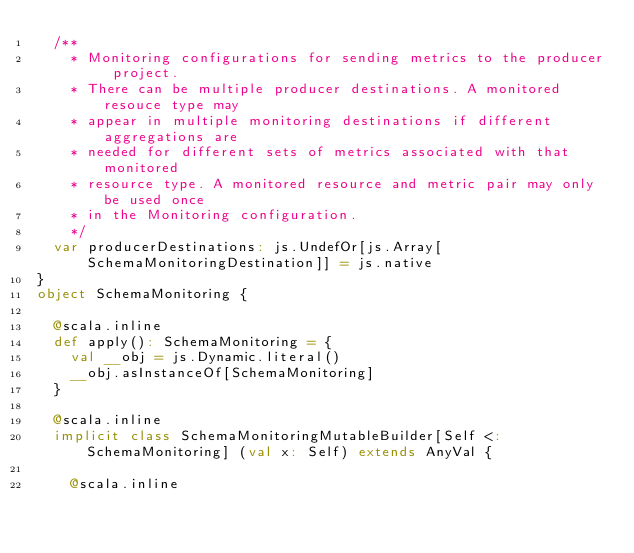<code> <loc_0><loc_0><loc_500><loc_500><_Scala_>  /**
    * Monitoring configurations for sending metrics to the producer project.
    * There can be multiple producer destinations. A monitored resouce type may
    * appear in multiple monitoring destinations if different aggregations are
    * needed for different sets of metrics associated with that monitored
    * resource type. A monitored resource and metric pair may only be used once
    * in the Monitoring configuration.
    */
  var producerDestinations: js.UndefOr[js.Array[SchemaMonitoringDestination]] = js.native
}
object SchemaMonitoring {
  
  @scala.inline
  def apply(): SchemaMonitoring = {
    val __obj = js.Dynamic.literal()
    __obj.asInstanceOf[SchemaMonitoring]
  }
  
  @scala.inline
  implicit class SchemaMonitoringMutableBuilder[Self <: SchemaMonitoring] (val x: Self) extends AnyVal {
    
    @scala.inline</code> 